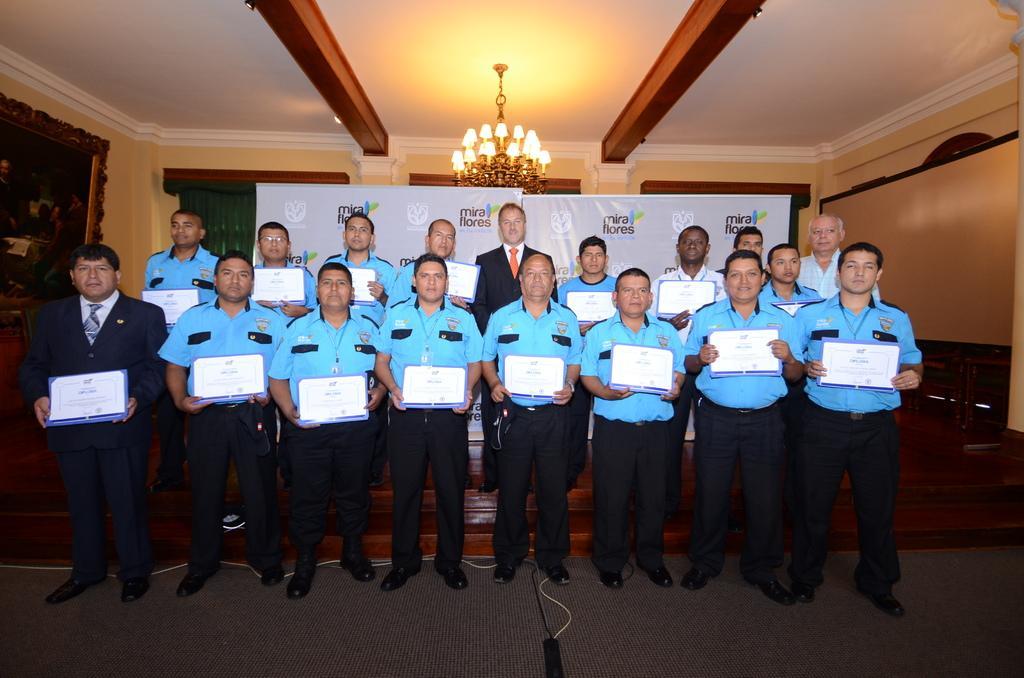How would you summarize this image in a sentence or two? In this image I can see there are group of persons standing and they are holding books and backside of them I can see hoarding boards and at the top I can see a roof, on the roof I can see chandelier lights and I can see the wall and a photo frame attached to the wall on the left side. 